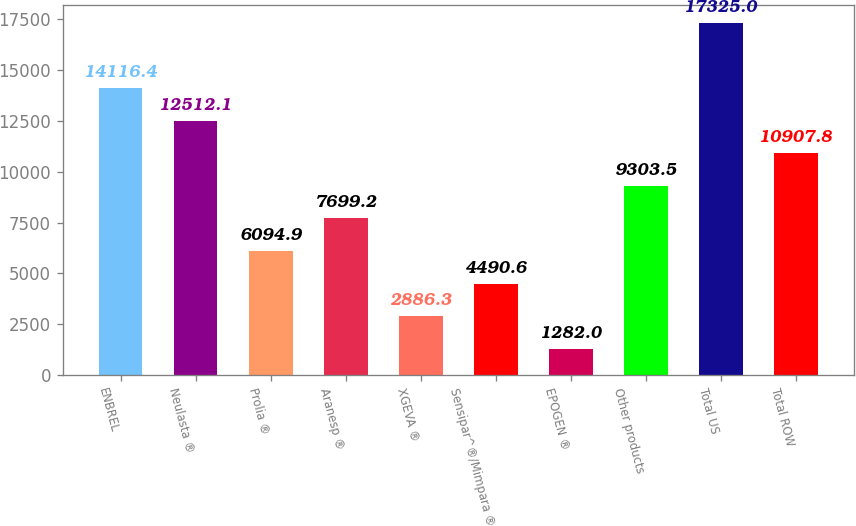<chart> <loc_0><loc_0><loc_500><loc_500><bar_chart><fcel>ENBREL<fcel>Neulasta ®<fcel>Prolia ®<fcel>Aranesp ®<fcel>XGEVA ®<fcel>Sensipar^®/Mimpara ®<fcel>EPOGEN ®<fcel>Other products<fcel>Total US<fcel>Total ROW<nl><fcel>14116.4<fcel>12512.1<fcel>6094.9<fcel>7699.2<fcel>2886.3<fcel>4490.6<fcel>1282<fcel>9303.5<fcel>17325<fcel>10907.8<nl></chart> 